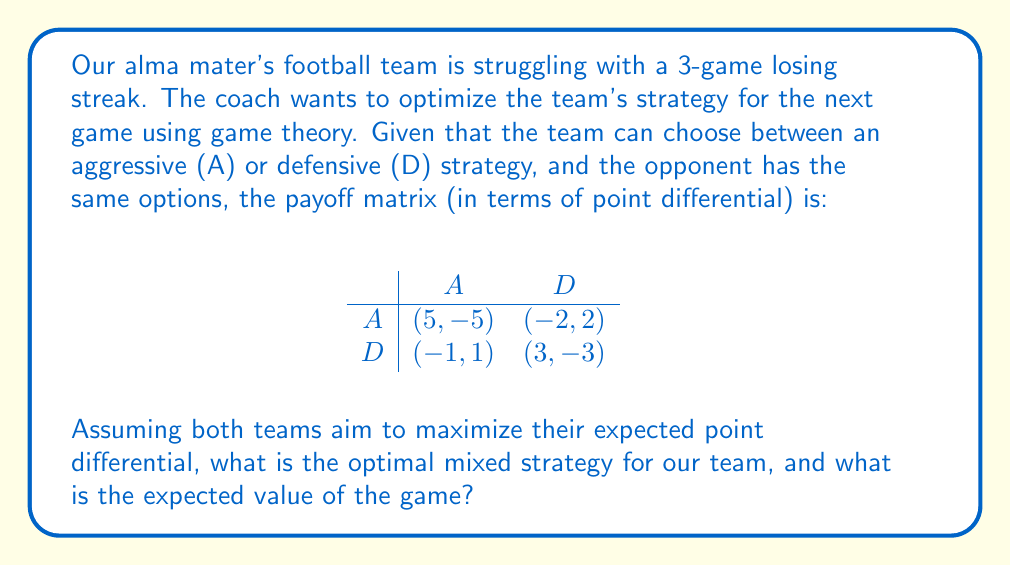Show me your answer to this math problem. To solve this problem, we'll use the concept of mixed strategy Nash equilibrium from game theory and apply nonlinear optimization techniques.

Step 1: Let $p$ be the probability of our team choosing strategy A, and $q$ be the probability of the opponent choosing strategy A.

Step 2: Calculate the expected payoff for our team:
$E = 5pq + (-2)p(1-q) + (-1)(1-p)q + 3(1-p)(1-q)$

Step 3: Simplify the equation:
$E = 5pq - 2p + 2pq - q + 3 - 3p - 3q + 3pq$
$E = 10pq - 5p - 4q + 3$

Step 4: To find the optimal strategy for our team, we need to find $p$ that maximizes $E$ regardless of what $q$ the opponent chooses. This occurs when:

$\frac{\partial E}{\partial q} = 10p - 4 = 0$

Step 5: Solve for $p$:
$10p - 4 = 0$
$10p = 4$
$p = 0.4$

Step 6: The opponent will use the same reasoning, so we can find $q$ by setting:

$\frac{\partial E}{\partial p} = 10q - 5 = 0$
$10q = 5$
$q = 0.5$

Step 7: Calculate the expected value of the game by substituting $p$ and $q$ into the equation from Step 3:
$E = 10(0.4)(0.5) - 5(0.4) - 4(0.5) + 3$
$E = 2 - 2 - 2 + 3 = 1$

Therefore, the optimal mixed strategy for our team is to play aggressively 40% of the time and defensively 60% of the time. The expected value of the game is 1 point in our favor.
Answer: Optimal strategy: (0.4A, 0.6D); Expected value: 1 point 